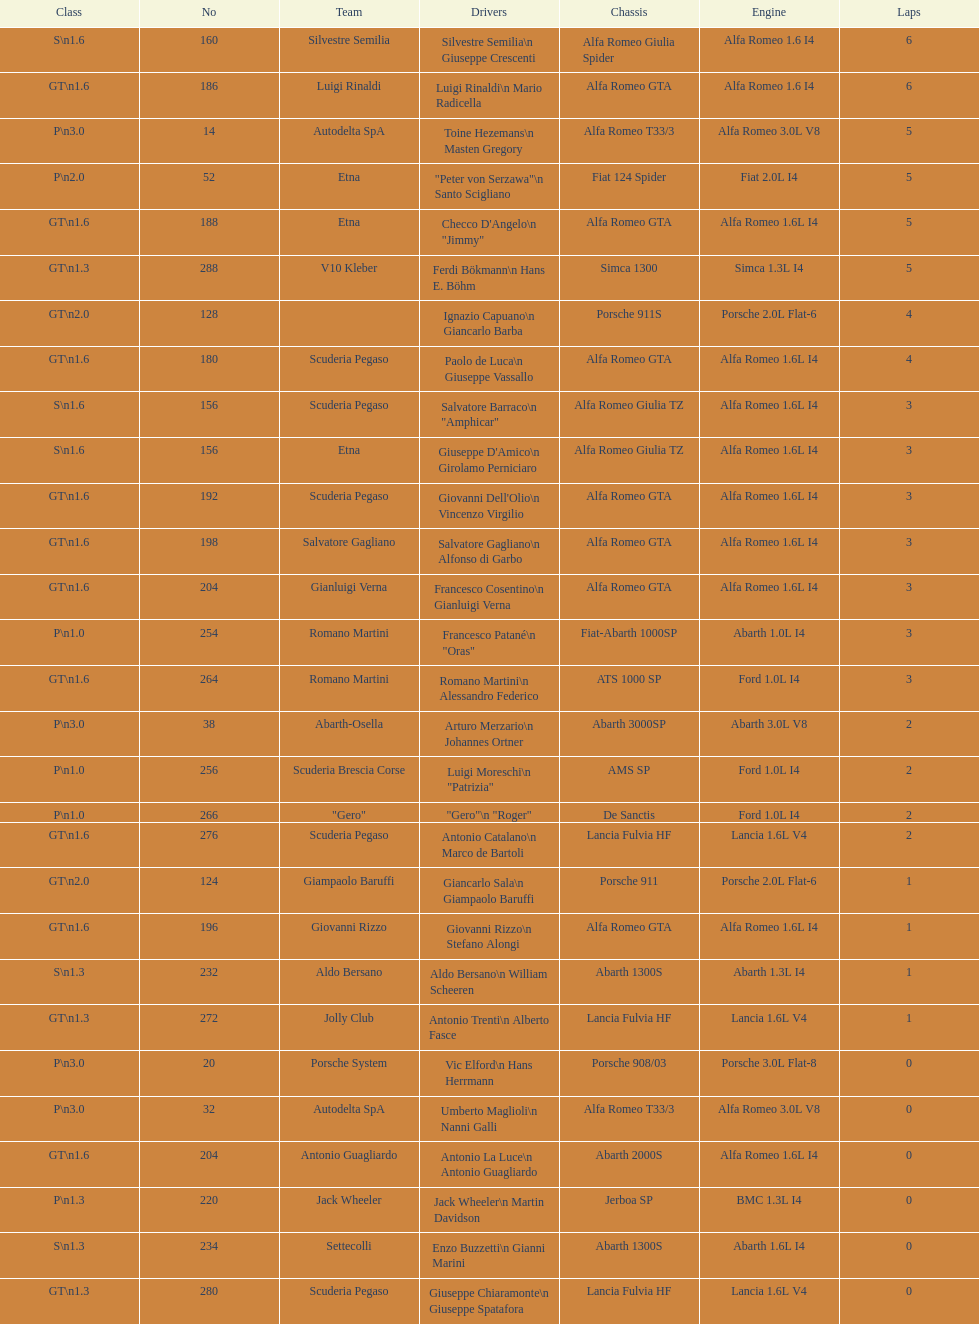How many teams did not finish the race after 2 laps? 4. 